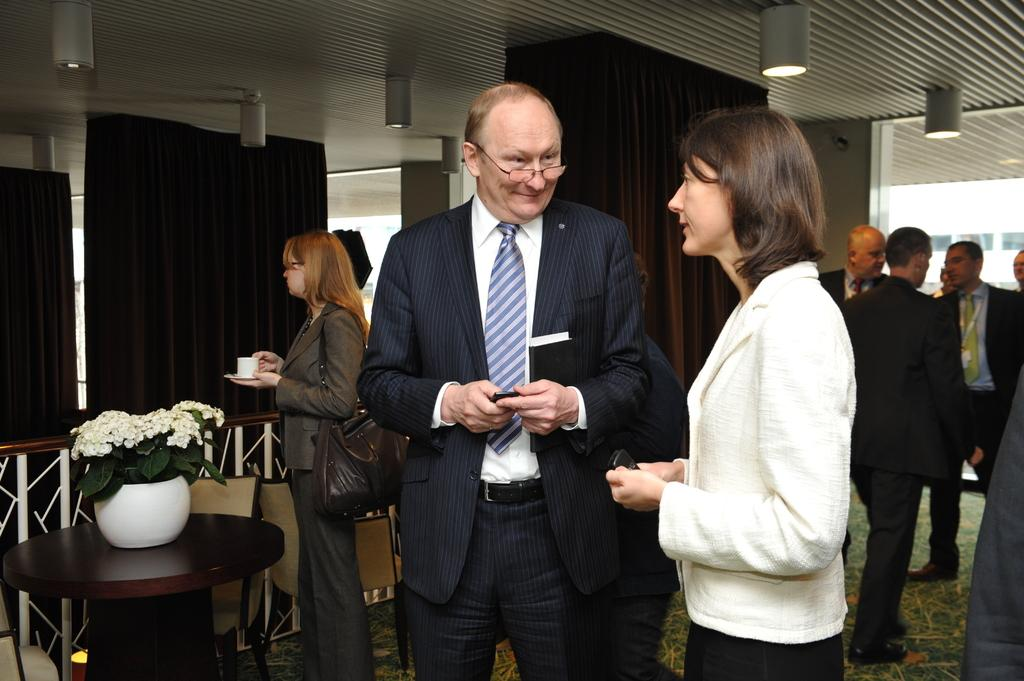How many people are in the room in the image? There is a group of people in the room in the image. What object can be seen on a table in the image? There is a pot on a table in the image. What type of material is visible in the background of the image? Cloth is present in the background of the image. Can you tell me how many goats are in the room in the image? There are no goats present in the room in the image. What type of earth is visible in the image? There is no earth visible in the image; it is an indoor scene. 